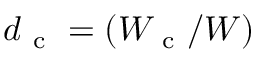<formula> <loc_0><loc_0><loc_500><loc_500>d _ { c } = ( W _ { c } / W )</formula> 